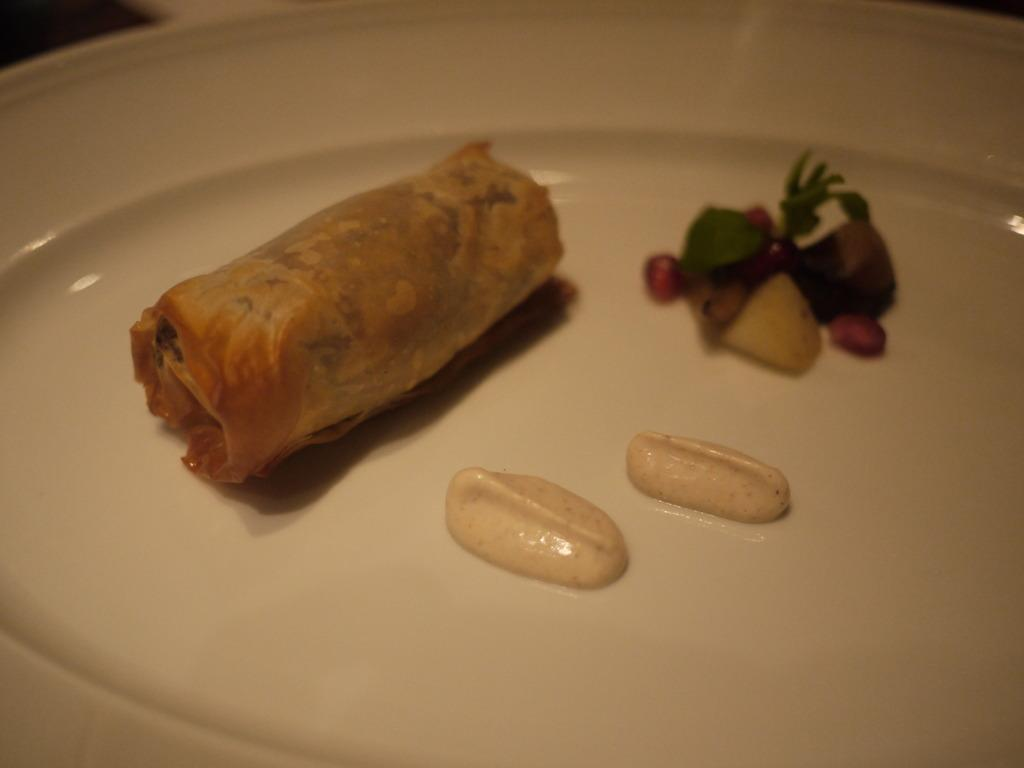What can be seen in the image? There are food items in the image. How are the food items arranged or presented? The food items are on a white plate. What type of muscle can be seen flexing in the image? There is no muscle present in the image; it features food items on a white plate. 